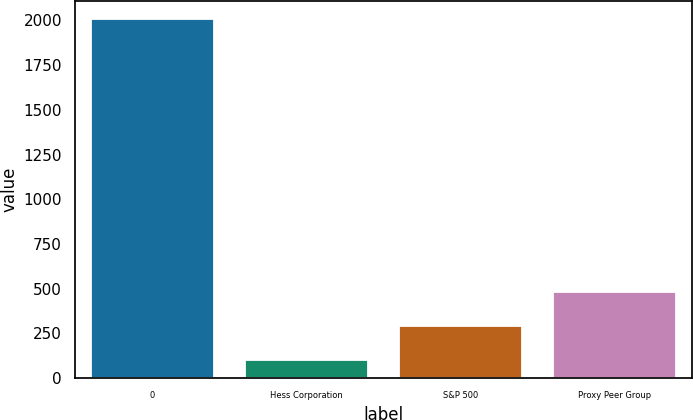Convert chart. <chart><loc_0><loc_0><loc_500><loc_500><bar_chart><fcel>0<fcel>Hess Corporation<fcel>S&P 500<fcel>Proxy Peer Group<nl><fcel>2008<fcel>100<fcel>290.8<fcel>481.6<nl></chart> 